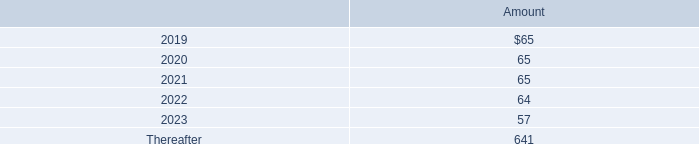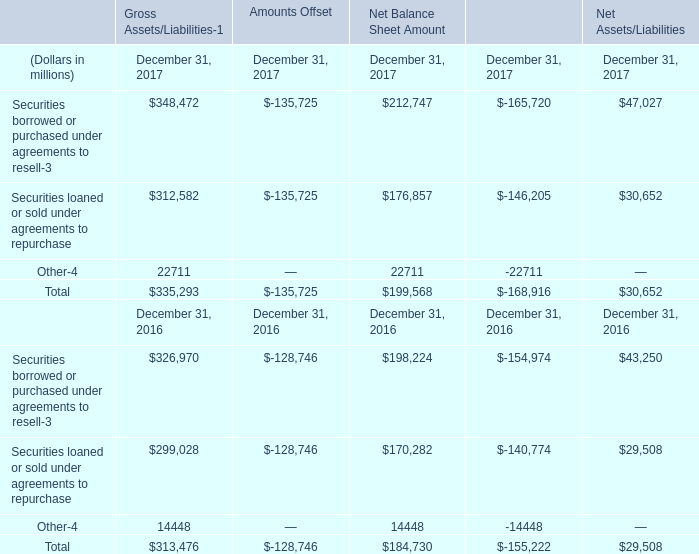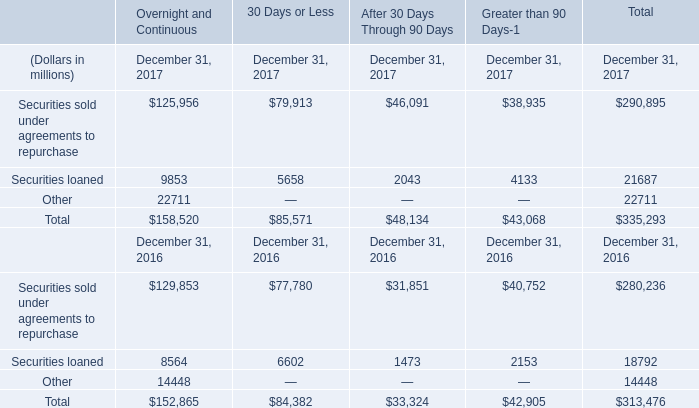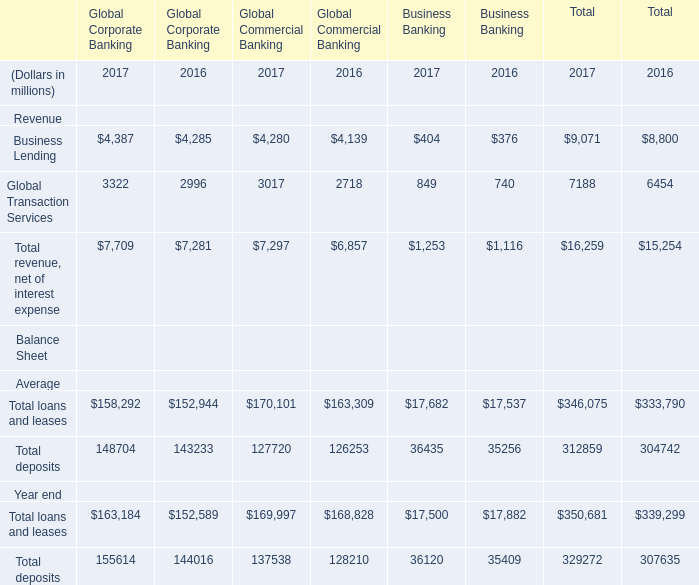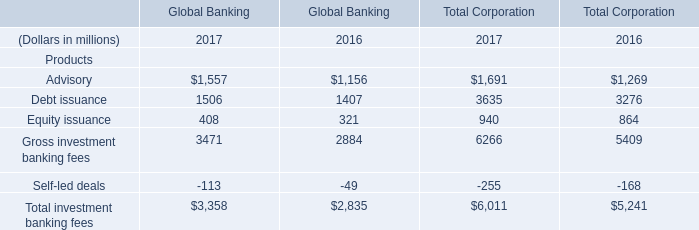In the year with the most Advisory, what is the growth rate of Total investment banking fees? 
Computations: ((((3358 + 6011) - 2835) - 5241) / (3358 + 6011))
Answer: 0.13801. 